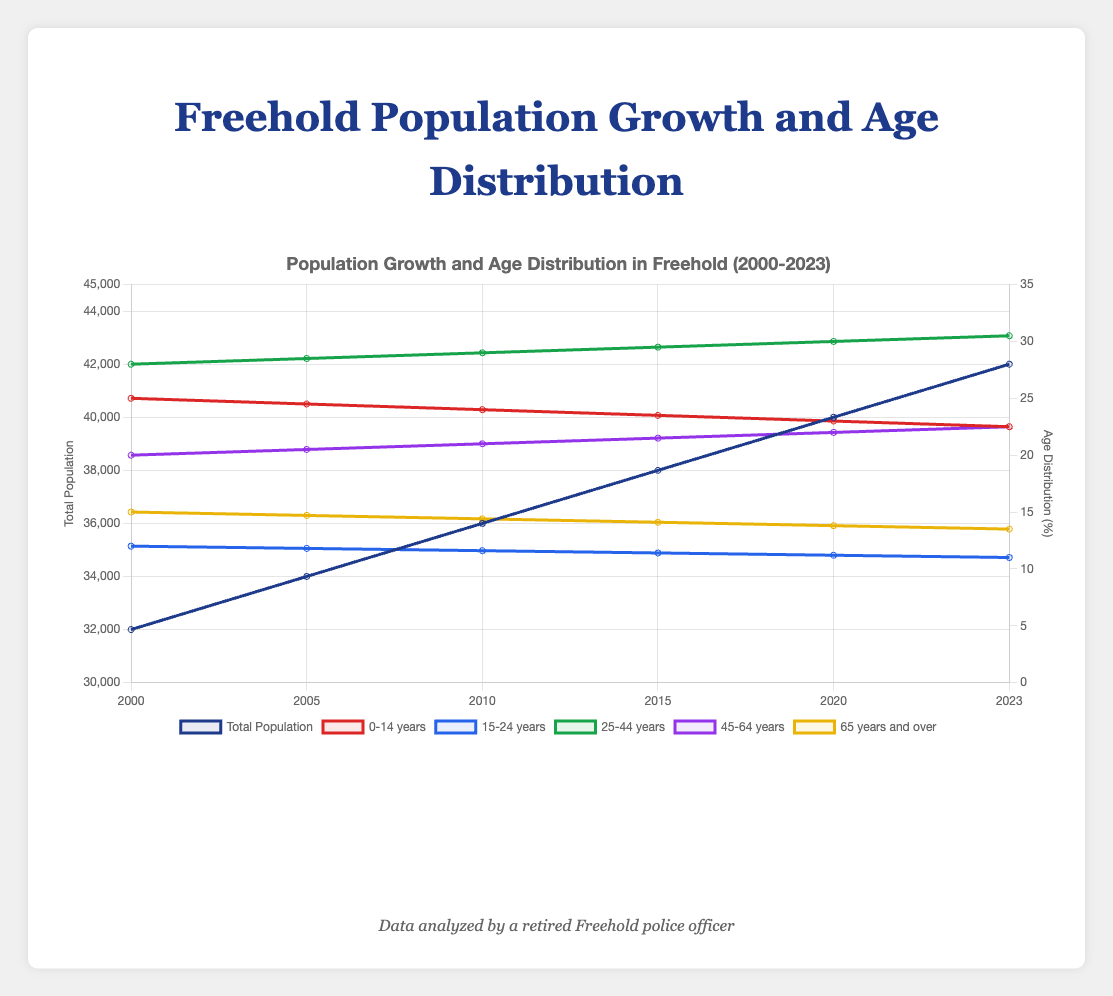What is the total population of Freehold in 2023? Check the figure for the 'Total Population' line and find the value for the year 2023, which is 42,000.
Answer: 42,000 What was the trend in the population aged 25-44 years from 2000 to 2023? Observe the line for '25-44 years' and note its continuous upward slope, starting from 28% in 2000 and reaching 30.5% in 2023, indicating a steady increase.
Answer: Steady increase Which age group had the highest percentage in 2023? By examining the height of the lines in 2023, the '25-44 years' group stands out at 30.5%, higher than all other age groups.
Answer: 25-44 years How did the percentage of the population aged 0-14 years change between 2000 and 2023? Find the percentage for the '0-14 years' group in 2000 and 2023, which shows a decline from 25.0% in 2000 to 22.5% in 2023. Calculate the difference: 25.0% - 22.5% = 2.5%.
Answer: Decreased by 2.5% Compare the population growth rates between 2000-2010 and 2010-2023. Calculate the growth for each period: from 2000 (32,000) to 2010 (36,000) is (36,000 - 32,000)/32,000 \* 100% = 12.5%. From 2010 (36,000) to 2023 (42,000) is (42,000 - 36,000)/36,000 \* 100% = 16.67%.
Answer: 16.67% is higher than 12.5% Between 2000 and 2023, which age group showed a consistent decrease in percentage? Check all age groups' lines: '0-14 years' consistently decreased from 25.0% to 22.5%, and '65 years and over' decreased from 15.0% to 13.5%. Both decreased, but the decrease for '65 years and over' was consistent.
Answer: 65 years and over In which year did the total population first reach 40,000 in Freehold? Look at the 'Total Population' line and see when it first crosses 40,000, which occurs in 2020.
Answer: 2020 What is the difference between the percentage of the population aged 45-64 years and the percentage aged 15-24 years in 2023? For 2023, the '45-64 years' group is 22.5%, and the '15-24 years' group is 11.0%. The difference is 22.5% - 11.0% = 11.5%.
Answer: 11.5% Which age group had a decreasing trend, and ended up at 13.5% in 2023? Review the lines and find that the group '65 years and over' had a decreasing trend and ends at 13.5% in 2023.
Answer: 65 years and over 